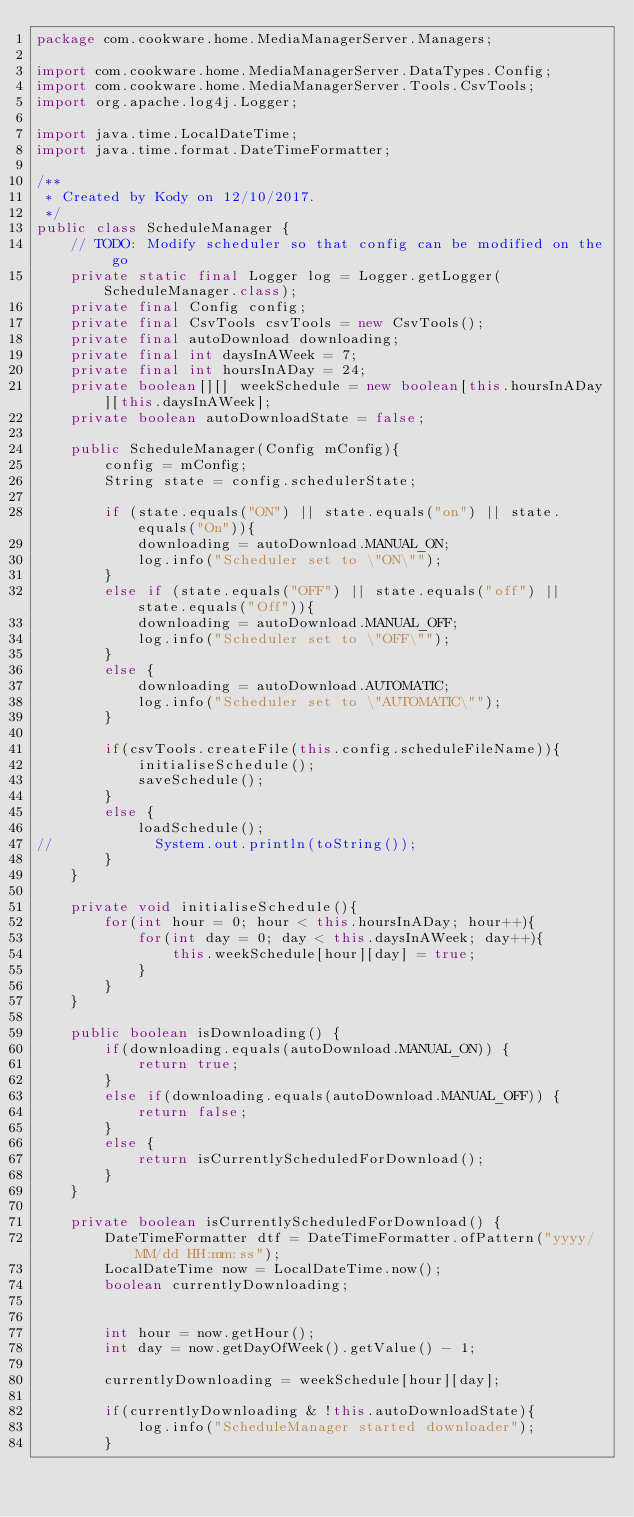<code> <loc_0><loc_0><loc_500><loc_500><_Java_>package com.cookware.home.MediaManagerServer.Managers;

import com.cookware.home.MediaManagerServer.DataTypes.Config;
import com.cookware.home.MediaManagerServer.Tools.CsvTools;
import org.apache.log4j.Logger;

import java.time.LocalDateTime;
import java.time.format.DateTimeFormatter;

/**
 * Created by Kody on 12/10/2017.
 */
public class ScheduleManager {
    // TODO: Modify scheduler so that config can be modified on the go
    private static final Logger log = Logger.getLogger(ScheduleManager.class);
    private final Config config;
    private final CsvTools csvTools = new CsvTools();
    private final autoDownload downloading;
    private final int daysInAWeek = 7;
    private final int hoursInADay = 24;
    private boolean[][] weekSchedule = new boolean[this.hoursInADay][this.daysInAWeek];
    private boolean autoDownloadState = false;

    public ScheduleManager(Config mConfig){
        config = mConfig;
        String state = config.schedulerState;

        if (state.equals("ON") || state.equals("on") || state.equals("On")){
            downloading = autoDownload.MANUAL_ON;
            log.info("Scheduler set to \"ON\"");
        }
        else if (state.equals("OFF") || state.equals("off") || state.equals("Off")){
            downloading = autoDownload.MANUAL_OFF;
            log.info("Scheduler set to \"OFF\"");
        }
        else {
            downloading = autoDownload.AUTOMATIC;
            log.info("Scheduler set to \"AUTOMATIC\"");
        }

        if(csvTools.createFile(this.config.scheduleFileName)){
            initialiseSchedule();
            saveSchedule();
        }
        else {
            loadSchedule();
//            System.out.println(toString());
        }
    }

    private void initialiseSchedule(){
        for(int hour = 0; hour < this.hoursInADay; hour++){
            for(int day = 0; day < this.daysInAWeek; day++){
                this.weekSchedule[hour][day] = true;
            }
        }
    }

    public boolean isDownloading() {
        if(downloading.equals(autoDownload.MANUAL_ON)) {
            return true;
        }
        else if(downloading.equals(autoDownload.MANUAL_OFF)) {
            return false;
        }
        else {
            return isCurrentlyScheduledForDownload();
        }
    }

    private boolean isCurrentlyScheduledForDownload() {
        DateTimeFormatter dtf = DateTimeFormatter.ofPattern("yyyy/MM/dd HH:mm:ss");
        LocalDateTime now = LocalDateTime.now();
        boolean currentlyDownloading;


        int hour = now.getHour();
        int day = now.getDayOfWeek().getValue() - 1;

        currentlyDownloading = weekSchedule[hour][day];

        if(currentlyDownloading & !this.autoDownloadState){
            log.info("ScheduleManager started downloader");
        }</code> 